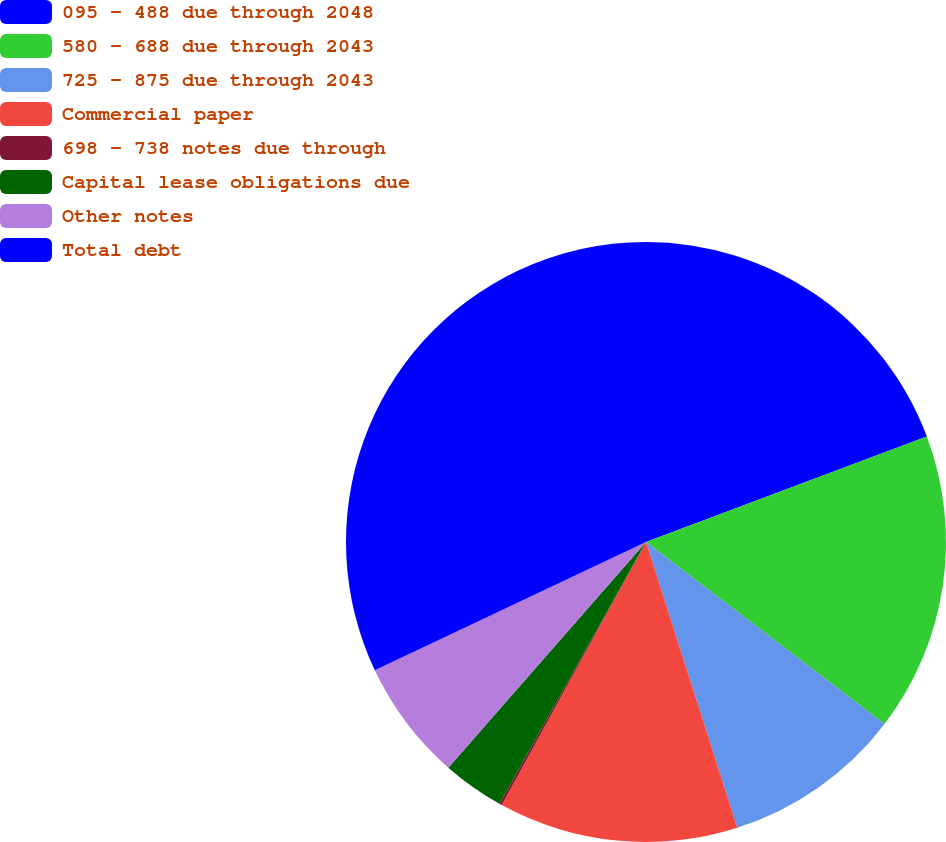<chart> <loc_0><loc_0><loc_500><loc_500><pie_chart><fcel>095 - 488 due through 2048<fcel>580 - 688 due through 2043<fcel>725 - 875 due through 2043<fcel>Commercial paper<fcel>698 - 738 notes due through<fcel>Capital lease obligations due<fcel>Other notes<fcel>Total debt<nl><fcel>19.28%<fcel>16.09%<fcel>9.71%<fcel>12.9%<fcel>0.14%<fcel>3.33%<fcel>6.52%<fcel>32.03%<nl></chart> 